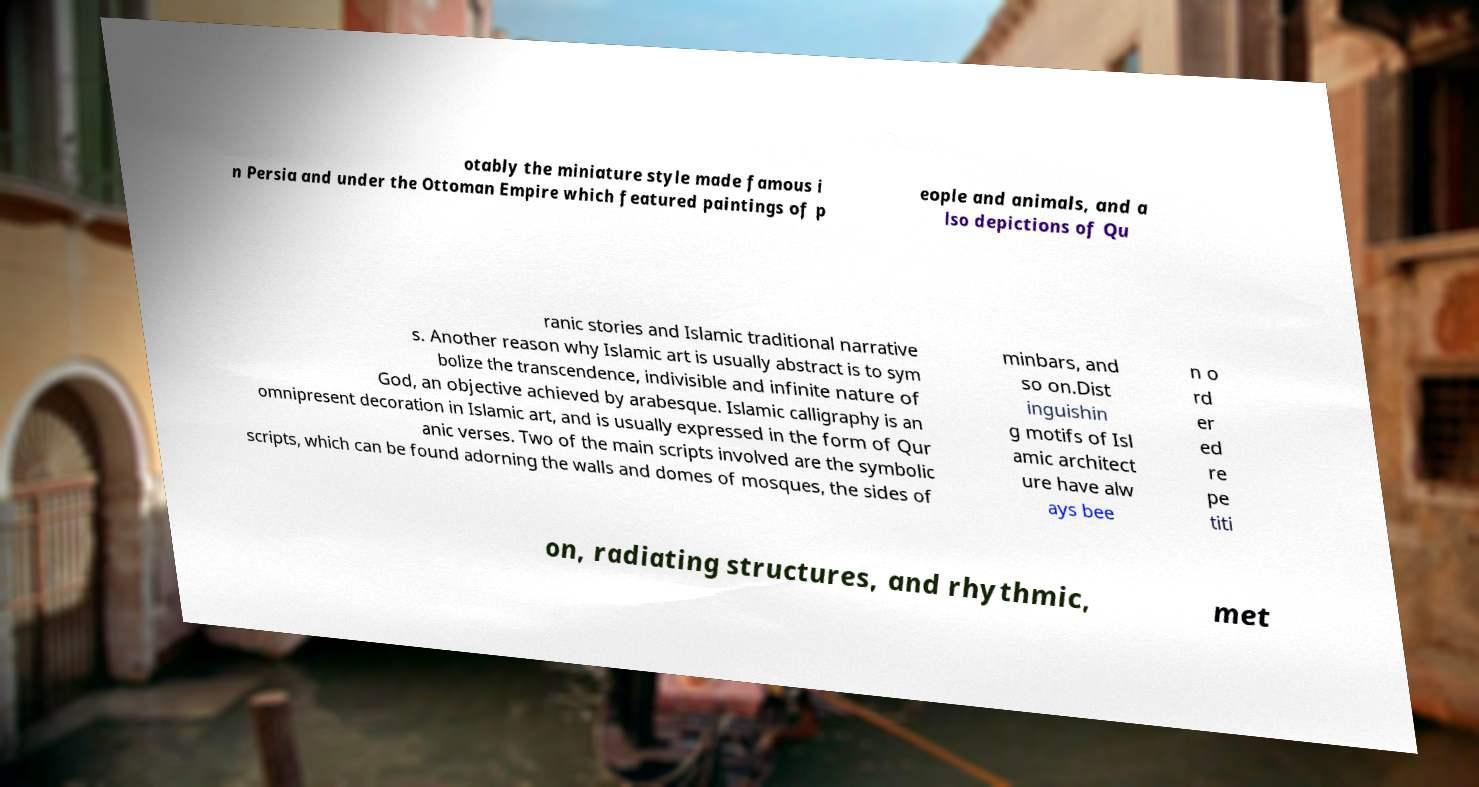What messages or text are displayed in this image? I need them in a readable, typed format. otably the miniature style made famous i n Persia and under the Ottoman Empire which featured paintings of p eople and animals, and a lso depictions of Qu ranic stories and Islamic traditional narrative s. Another reason why Islamic art is usually abstract is to sym bolize the transcendence, indivisible and infinite nature of God, an objective achieved by arabesque. Islamic calligraphy is an omnipresent decoration in Islamic art, and is usually expressed in the form of Qur anic verses. Two of the main scripts involved are the symbolic scripts, which can be found adorning the walls and domes of mosques, the sides of minbars, and so on.Dist inguishin g motifs of Isl amic architect ure have alw ays bee n o rd er ed re pe titi on, radiating structures, and rhythmic, met 